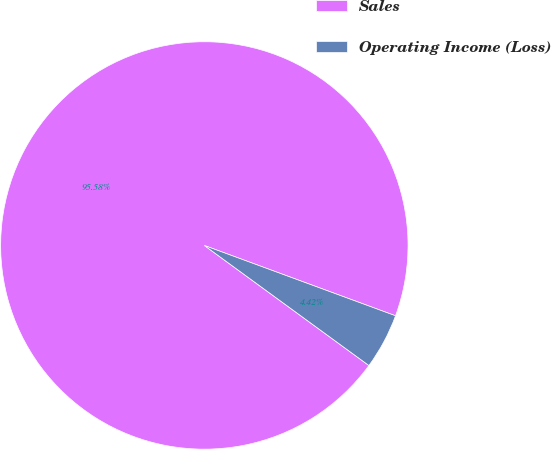Convert chart. <chart><loc_0><loc_0><loc_500><loc_500><pie_chart><fcel>Sales<fcel>Operating Income (Loss)<nl><fcel>95.58%<fcel>4.42%<nl></chart> 